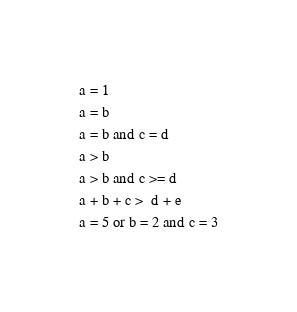Convert code to text. <code><loc_0><loc_0><loc_500><loc_500><_SQL_>a = 1
a = b
a = b and c = d
a > b
a > b and c >= d
a + b + c >  d + e
a = 5 or b = 2 and c = 3
</code> 